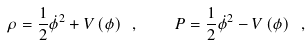<formula> <loc_0><loc_0><loc_500><loc_500>\rho = \frac { 1 } { 2 } \dot { \phi } ^ { 2 } + V \left ( \phi \right ) \ , \quad P = \frac { 1 } { 2 } \dot { \phi } ^ { 2 } - V \left ( \phi \right ) \ ,</formula> 